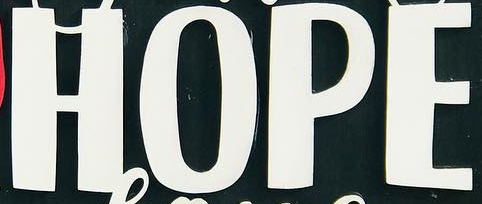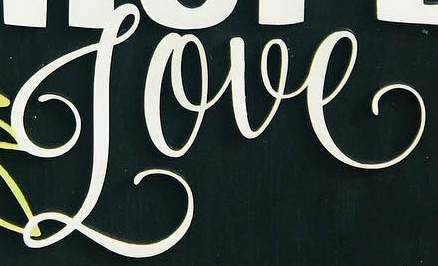What text appears in these images from left to right, separated by a semicolon? HOPE; Love 